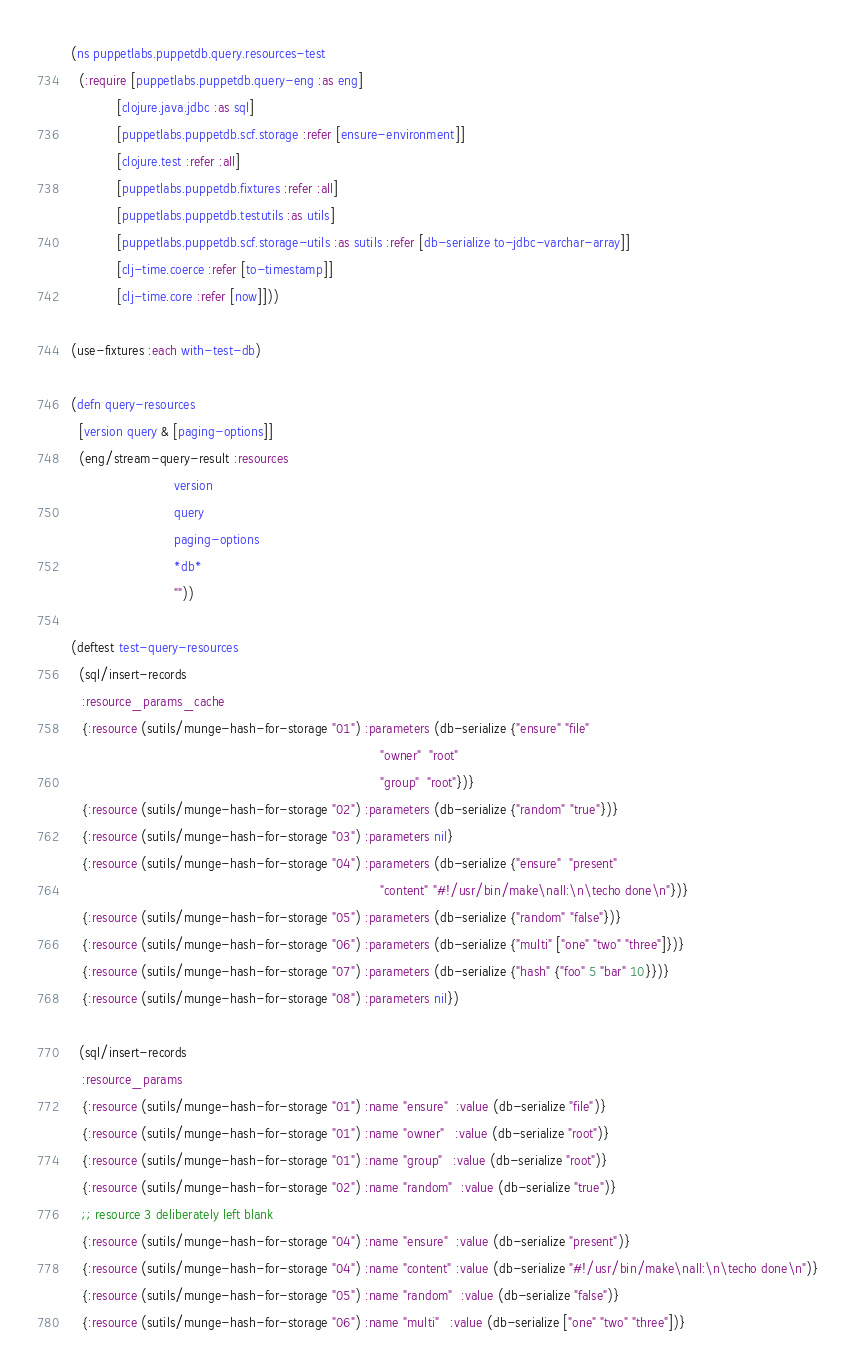Convert code to text. <code><loc_0><loc_0><loc_500><loc_500><_Clojure_>(ns puppetlabs.puppetdb.query.resources-test
  (:require [puppetlabs.puppetdb.query-eng :as eng]
            [clojure.java.jdbc :as sql]
            [puppetlabs.puppetdb.scf.storage :refer [ensure-environment]]
            [clojure.test :refer :all]
            [puppetlabs.puppetdb.fixtures :refer :all]
            [puppetlabs.puppetdb.testutils :as utils]
            [puppetlabs.puppetdb.scf.storage-utils :as sutils :refer [db-serialize to-jdbc-varchar-array]]
            [clj-time.coerce :refer [to-timestamp]]
            [clj-time.core :refer [now]]))

(use-fixtures :each with-test-db)

(defn query-resources
  [version query & [paging-options]]
  (eng/stream-query-result :resources
                           version
                           query
                           paging-options
                           *db*
                           ""))

(deftest test-query-resources
  (sql/insert-records
   :resource_params_cache
   {:resource (sutils/munge-hash-for-storage "01") :parameters (db-serialize {"ensure" "file"
                                                                                 "owner"  "root"
                                                                                 "group"  "root"})}
   {:resource (sutils/munge-hash-for-storage "02") :parameters (db-serialize {"random" "true"})}
   {:resource (sutils/munge-hash-for-storage "03") :parameters nil}
   {:resource (sutils/munge-hash-for-storage "04") :parameters (db-serialize {"ensure"  "present"
                                                                                 "content" "#!/usr/bin/make\nall:\n\techo done\n"})}
   {:resource (sutils/munge-hash-for-storage "05") :parameters (db-serialize {"random" "false"})}
   {:resource (sutils/munge-hash-for-storage "06") :parameters (db-serialize {"multi" ["one" "two" "three"]})}
   {:resource (sutils/munge-hash-for-storage "07") :parameters (db-serialize {"hash" {"foo" 5 "bar" 10}})}
   {:resource (sutils/munge-hash-for-storage "08") :parameters nil})

  (sql/insert-records
   :resource_params
   {:resource (sutils/munge-hash-for-storage "01") :name "ensure"  :value (db-serialize "file")}
   {:resource (sutils/munge-hash-for-storage "01") :name "owner"   :value (db-serialize "root")}
   {:resource (sutils/munge-hash-for-storage "01") :name "group"   :value (db-serialize "root")}
   {:resource (sutils/munge-hash-for-storage "02") :name "random"  :value (db-serialize "true")}
   ;; resource 3 deliberately left blank
   {:resource (sutils/munge-hash-for-storage "04") :name "ensure"  :value (db-serialize "present")}
   {:resource (sutils/munge-hash-for-storage "04") :name "content" :value (db-serialize "#!/usr/bin/make\nall:\n\techo done\n")}
   {:resource (sutils/munge-hash-for-storage "05") :name "random"  :value (db-serialize "false")}
   {:resource (sutils/munge-hash-for-storage "06") :name "multi"   :value (db-serialize ["one" "two" "three"])}</code> 